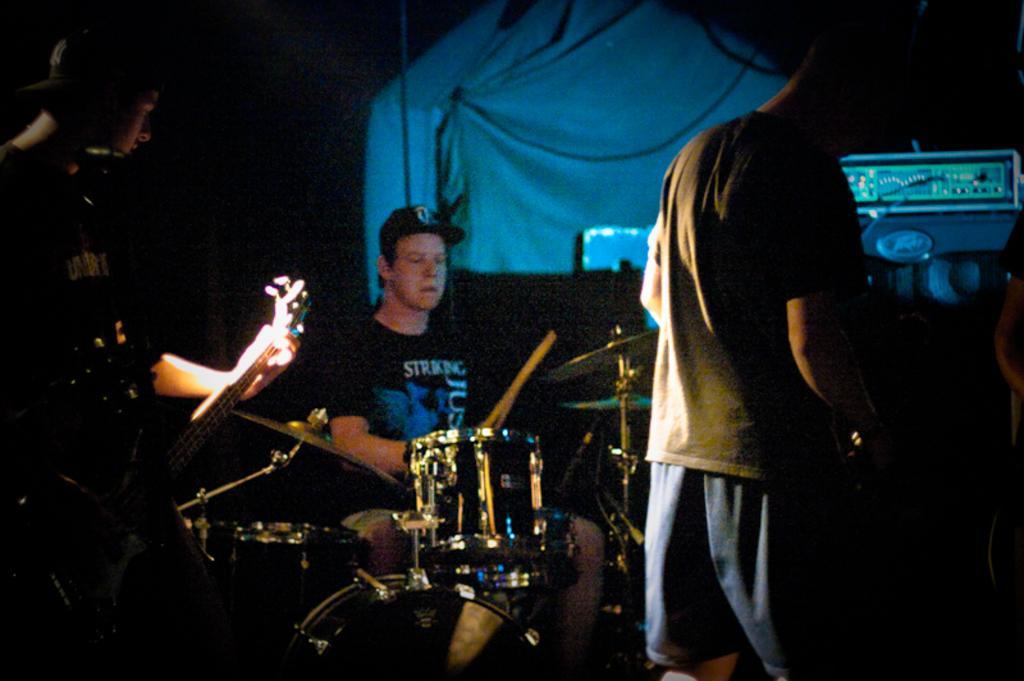In one or two sentences, can you explain what this image depicts? In this image there are three persons who are playing musical instruments at the left side of the image there is a person who is playing guitar at the background there is a tent and at the right side of the image there is a person who is operating a musical instrument. 